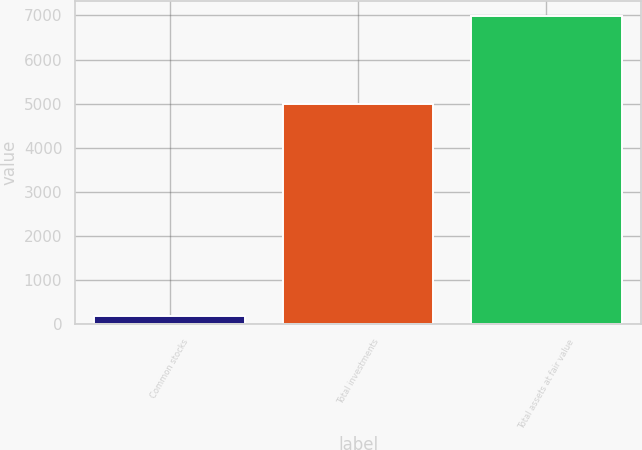Convert chart to OTSL. <chart><loc_0><loc_0><loc_500><loc_500><bar_chart><fcel>Common stocks<fcel>Total investments<fcel>Total assets at fair value<nl><fcel>192<fcel>5002<fcel>6983<nl></chart> 